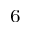<formula> <loc_0><loc_0><loc_500><loc_500>^ { 6 }</formula> 